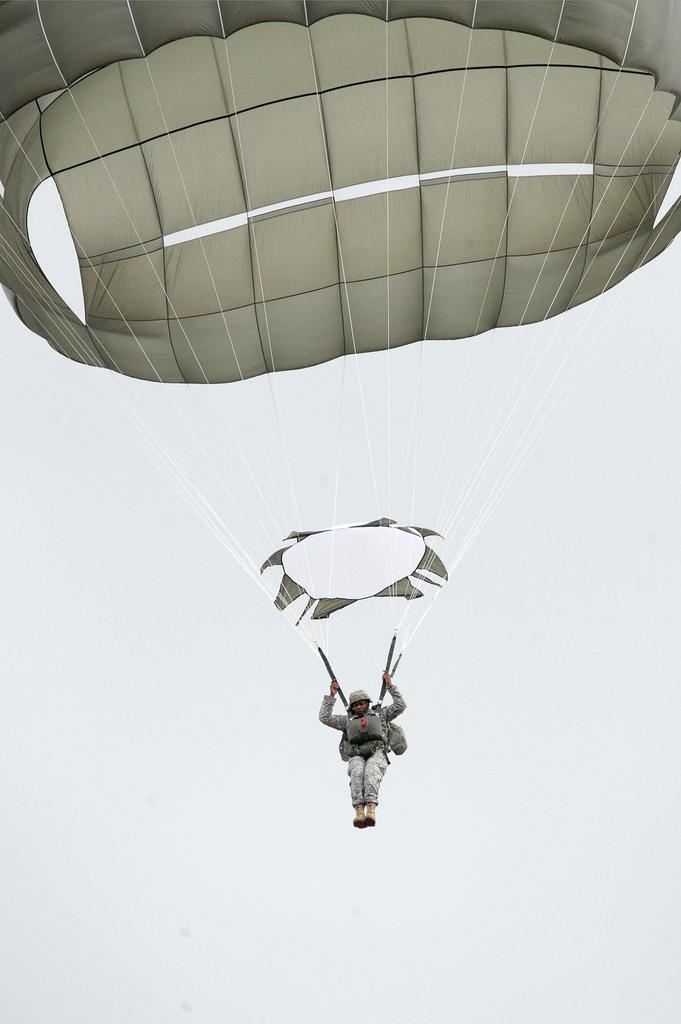What is the main subject of the image? There is a person in the image. What activity is the person engaged in? The person appears to be paragliding. What can be seen in the background of the image? The background of the image is the sky. What type of bushes can be seen in the frame of the image? There are no bushes present in the image, and the term "frame" is not applicable to this context. The image is a photograph or digital representation, not a physical object with a frame. 